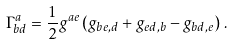Convert formula to latex. <formula><loc_0><loc_0><loc_500><loc_500>\Gamma ^ { a } _ { b d } = \frac { 1 } { 2 } g ^ { a e } \left ( g _ { b e , d } + g _ { e d , b } - g _ { b d , e } \right ) \, .</formula> 